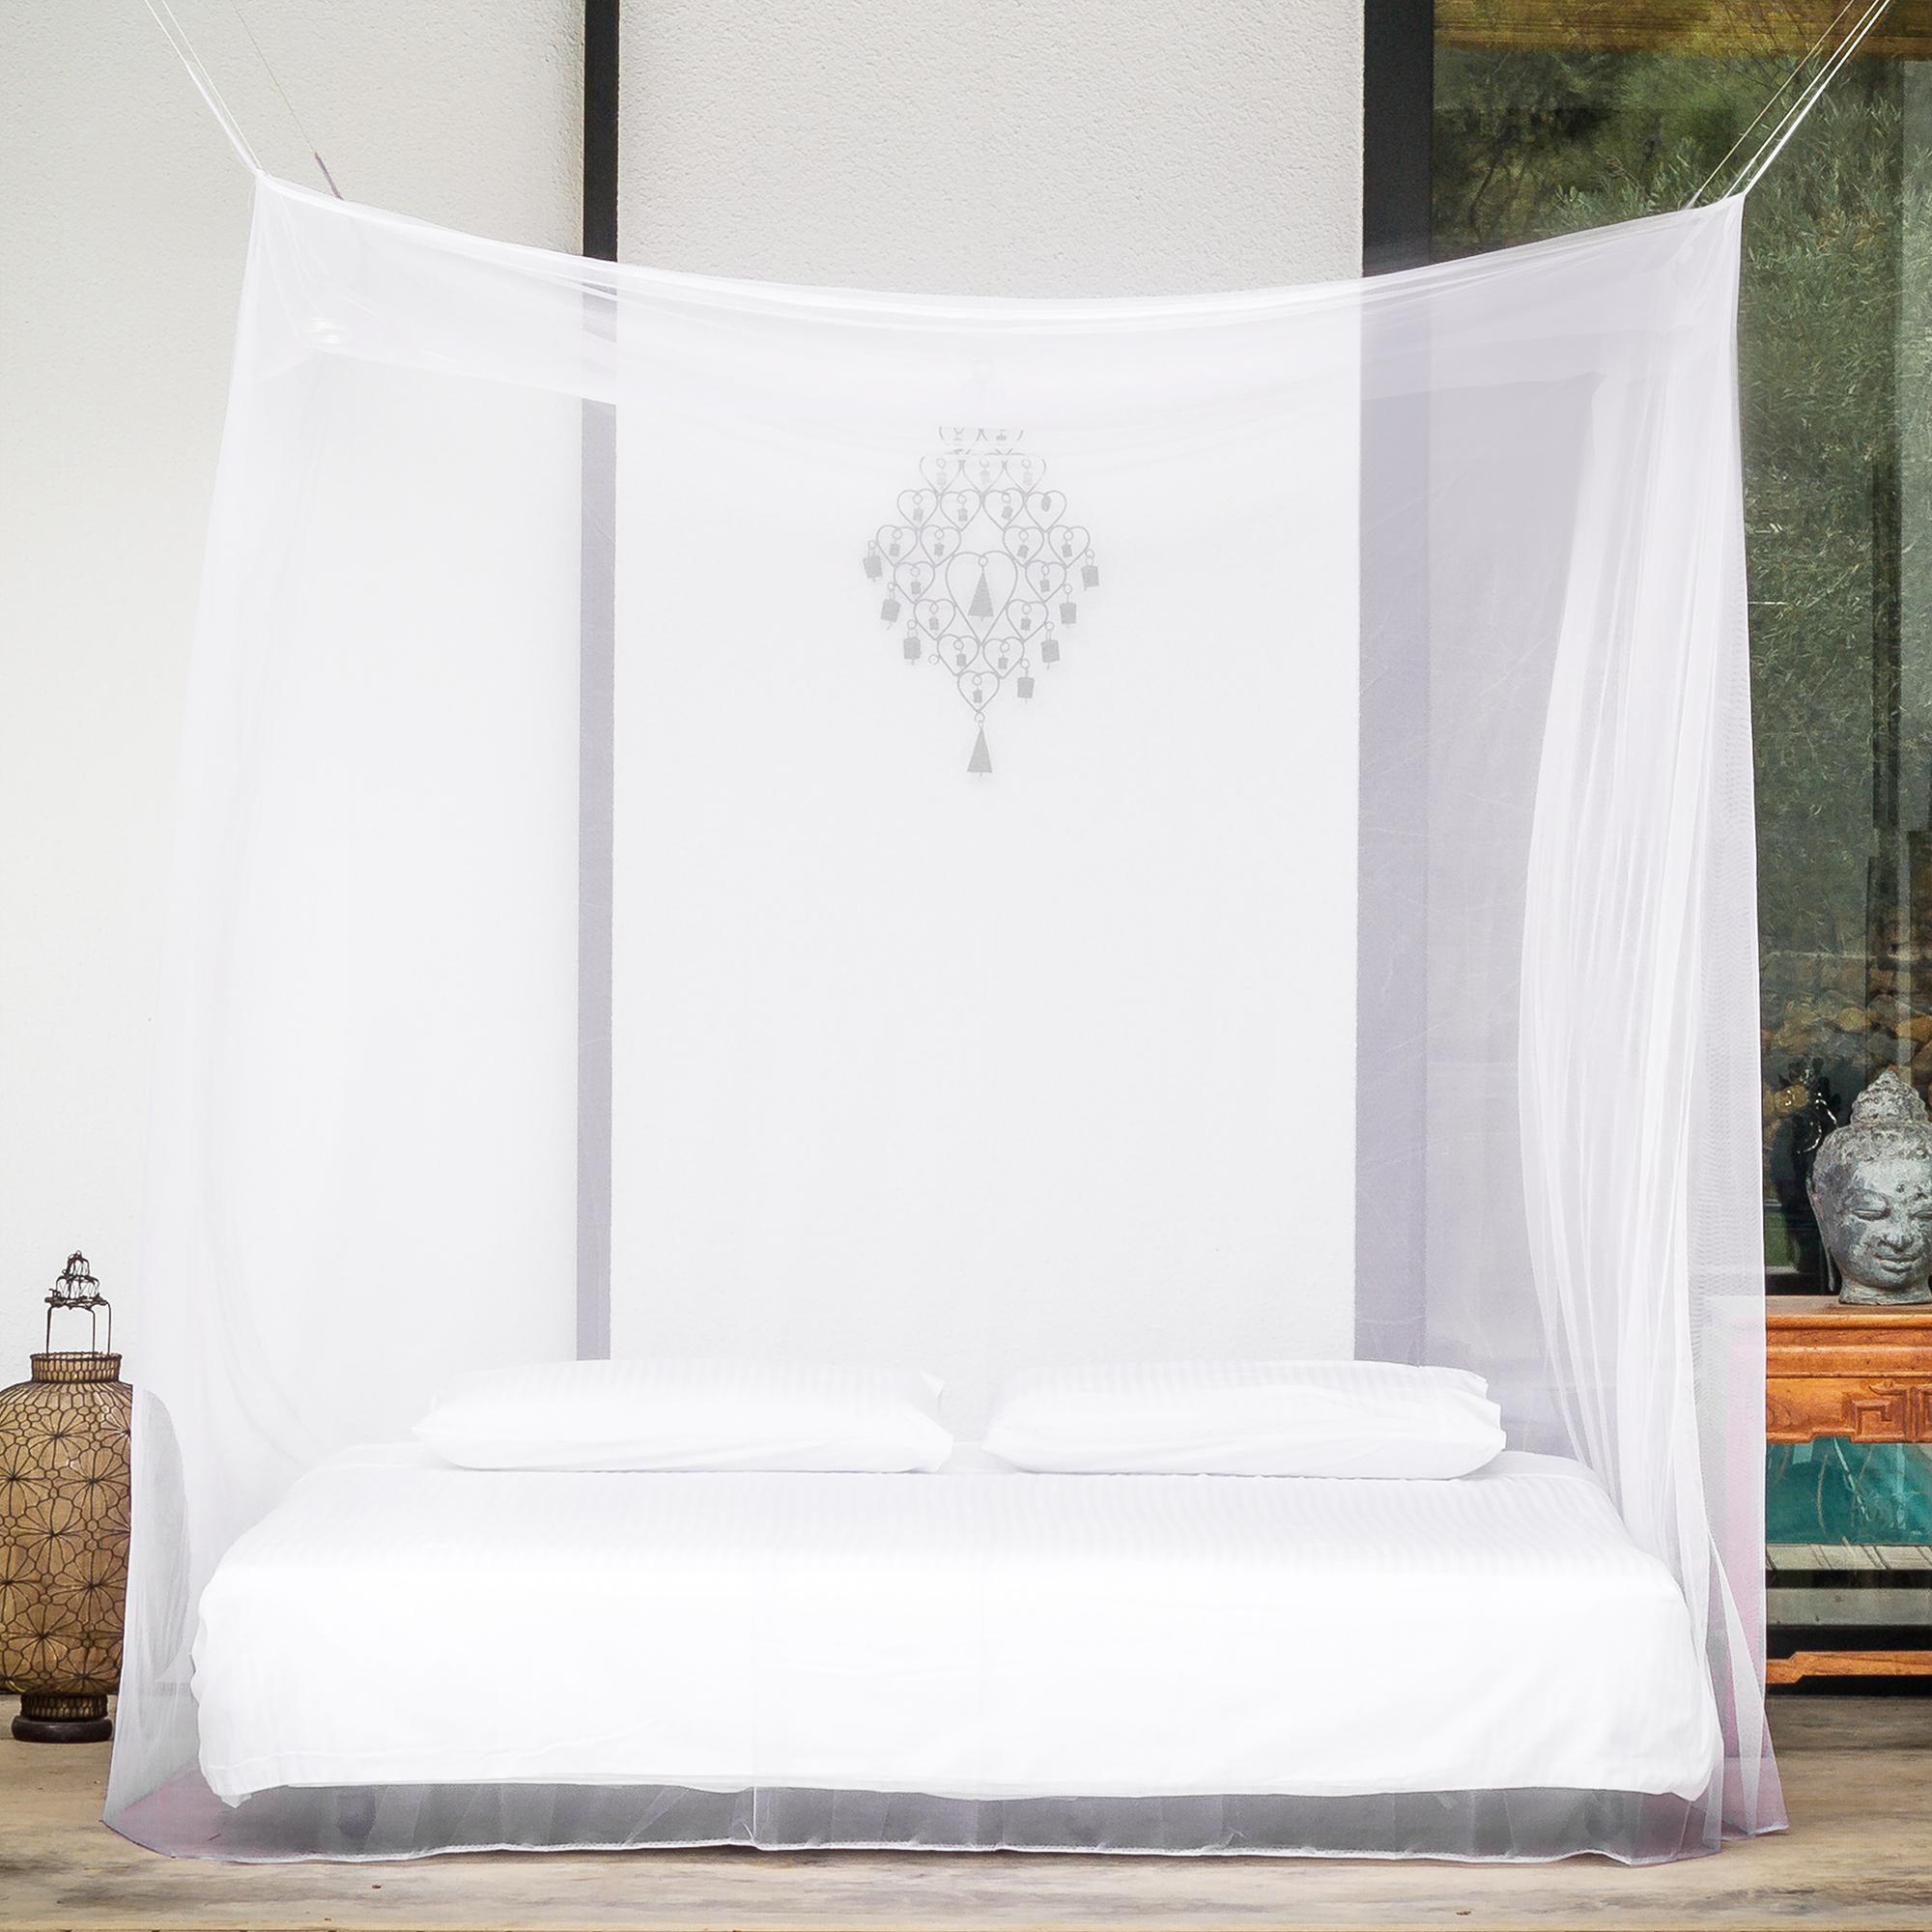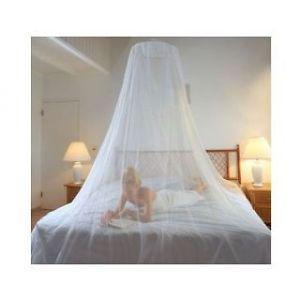The first image is the image on the left, the second image is the image on the right. Considering the images on both sides, is "There are two circle canopies." valid? Answer yes or no. No. The first image is the image on the left, the second image is the image on the right. Considering the images on both sides, is "There are two white round canopies." valid? Answer yes or no. No. 